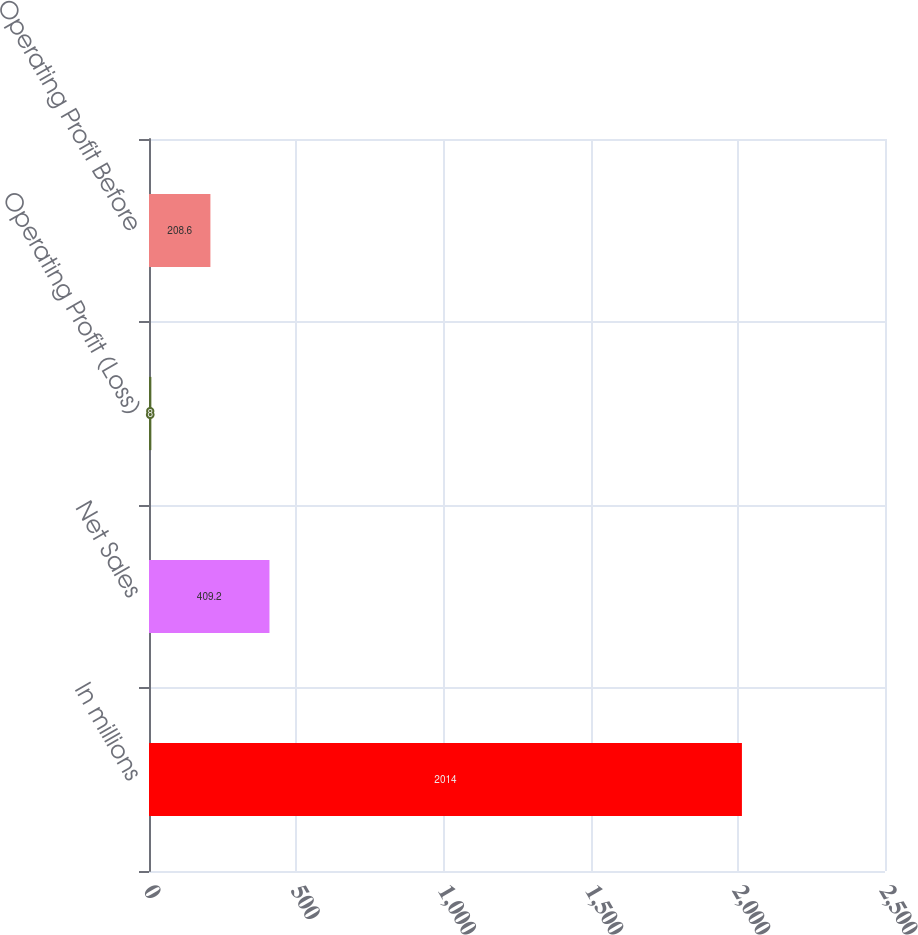<chart> <loc_0><loc_0><loc_500><loc_500><bar_chart><fcel>In millions<fcel>Net Sales<fcel>Operating Profit (Loss)<fcel>Operating Profit Before<nl><fcel>2014<fcel>409.2<fcel>8<fcel>208.6<nl></chart> 